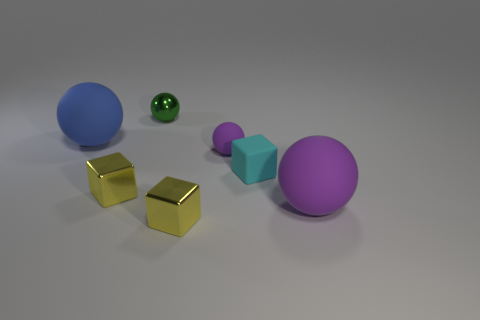Subtract all yellow balls. Subtract all brown cylinders. How many balls are left? 4 Add 2 large purple objects. How many objects exist? 9 Subtract all blocks. How many objects are left? 4 Add 6 tiny green balls. How many tiny green balls are left? 7 Add 4 large green metallic cylinders. How many large green metallic cylinders exist? 4 Subtract 0 gray cylinders. How many objects are left? 7 Subtract all large blue matte balls. Subtract all yellow metallic objects. How many objects are left? 4 